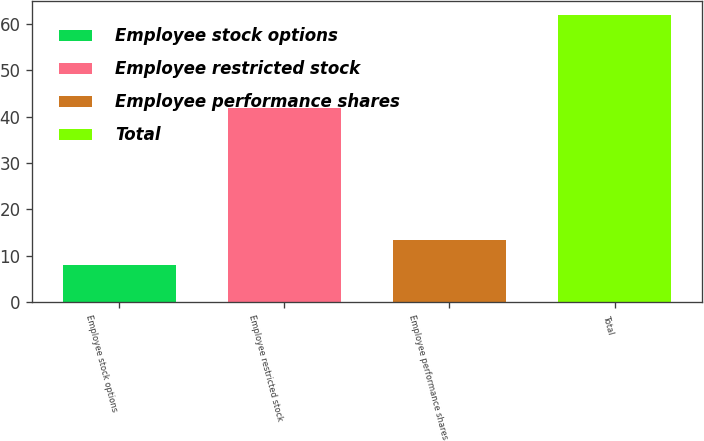Convert chart to OTSL. <chart><loc_0><loc_0><loc_500><loc_500><bar_chart><fcel>Employee stock options<fcel>Employee restricted stock<fcel>Employee performance shares<fcel>Total<nl><fcel>8<fcel>42<fcel>13.4<fcel>62<nl></chart> 